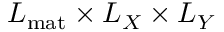<formula> <loc_0><loc_0><loc_500><loc_500>L _ { m a t } \times L _ { X } \times L _ { Y }</formula> 